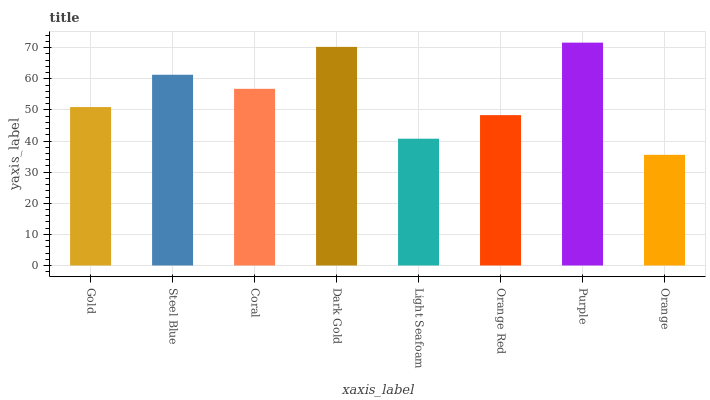Is Orange the minimum?
Answer yes or no. Yes. Is Purple the maximum?
Answer yes or no. Yes. Is Steel Blue the minimum?
Answer yes or no. No. Is Steel Blue the maximum?
Answer yes or no. No. Is Steel Blue greater than Gold?
Answer yes or no. Yes. Is Gold less than Steel Blue?
Answer yes or no. Yes. Is Gold greater than Steel Blue?
Answer yes or no. No. Is Steel Blue less than Gold?
Answer yes or no. No. Is Coral the high median?
Answer yes or no. Yes. Is Gold the low median?
Answer yes or no. Yes. Is Purple the high median?
Answer yes or no. No. Is Coral the low median?
Answer yes or no. No. 